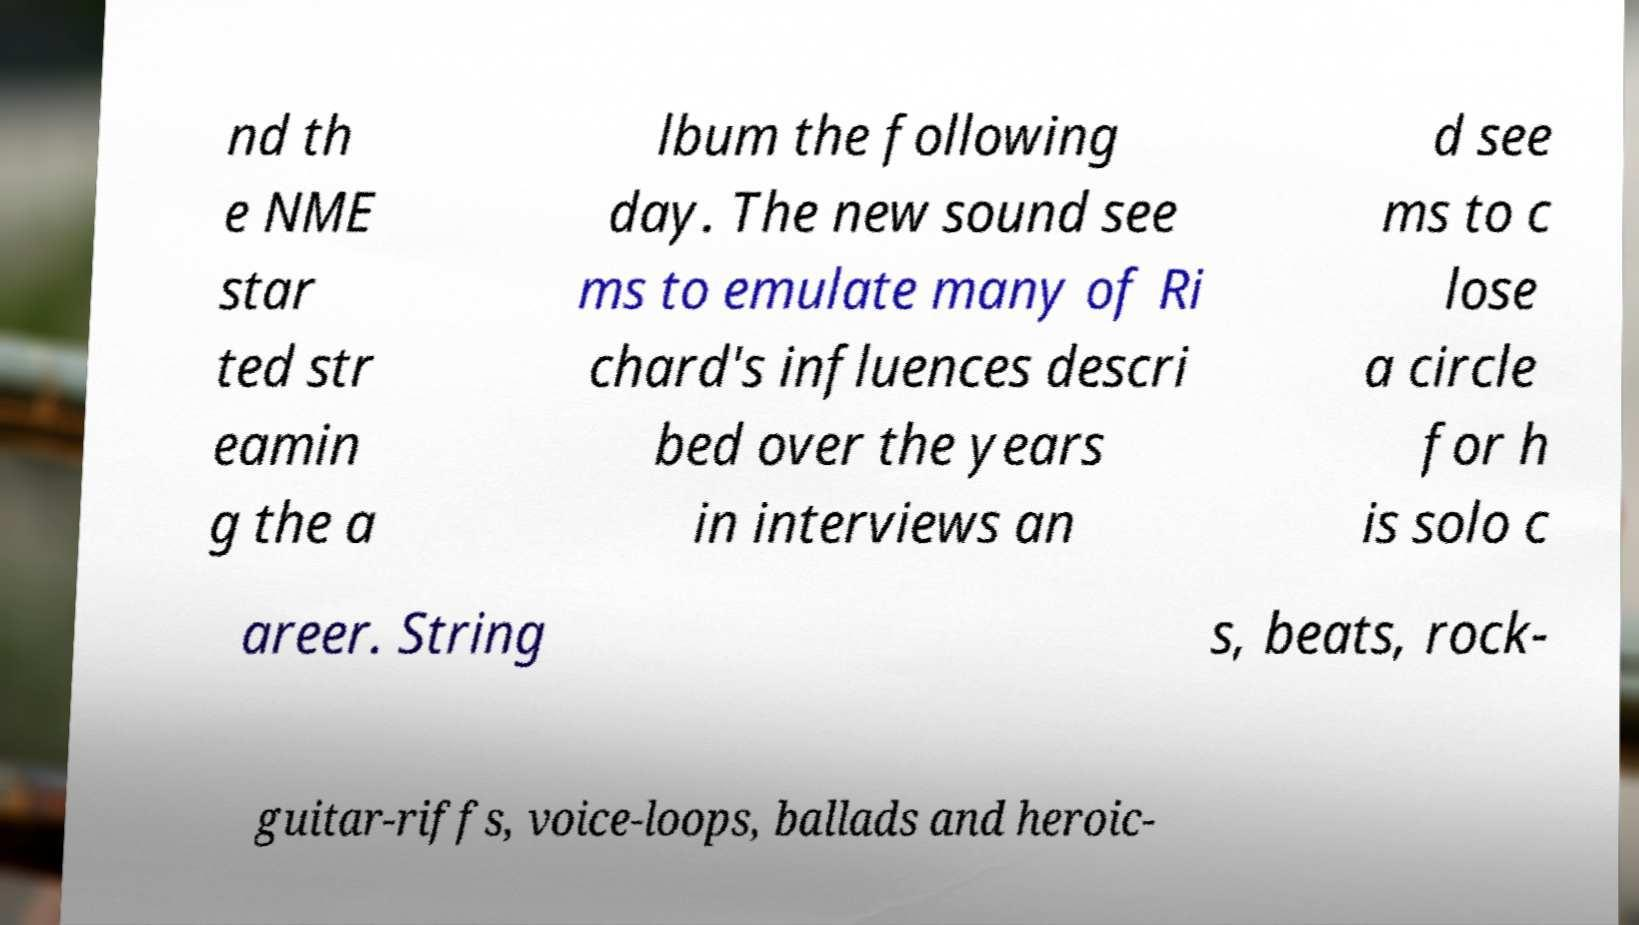I need the written content from this picture converted into text. Can you do that? nd th e NME star ted str eamin g the a lbum the following day. The new sound see ms to emulate many of Ri chard's influences descri bed over the years in interviews an d see ms to c lose a circle for h is solo c areer. String s, beats, rock- guitar-riffs, voice-loops, ballads and heroic- 